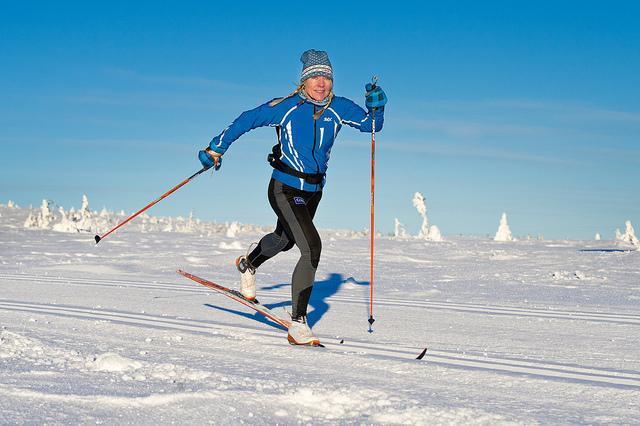How many bears are white?
Give a very brief answer. 0. 